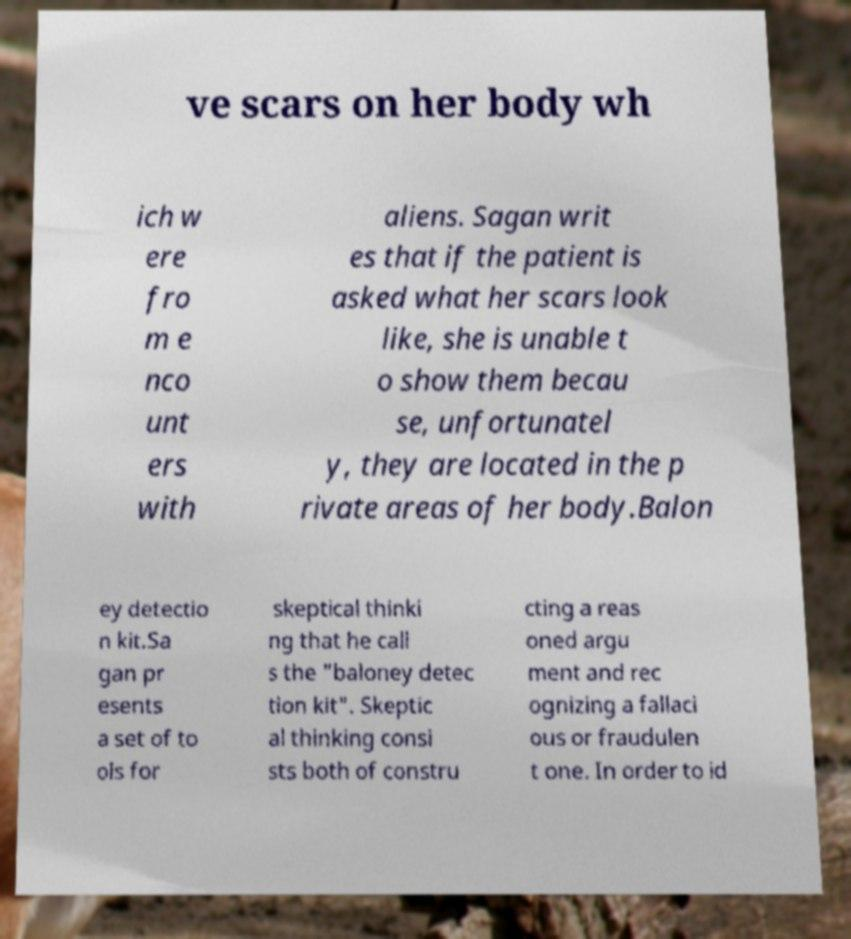Could you extract and type out the text from this image? ve scars on her body wh ich w ere fro m e nco unt ers with aliens. Sagan writ es that if the patient is asked what her scars look like, she is unable t o show them becau se, unfortunatel y, they are located in the p rivate areas of her body.Balon ey detectio n kit.Sa gan pr esents a set of to ols for skeptical thinki ng that he call s the "baloney detec tion kit". Skeptic al thinking consi sts both of constru cting a reas oned argu ment and rec ognizing a fallaci ous or fraudulen t one. In order to id 